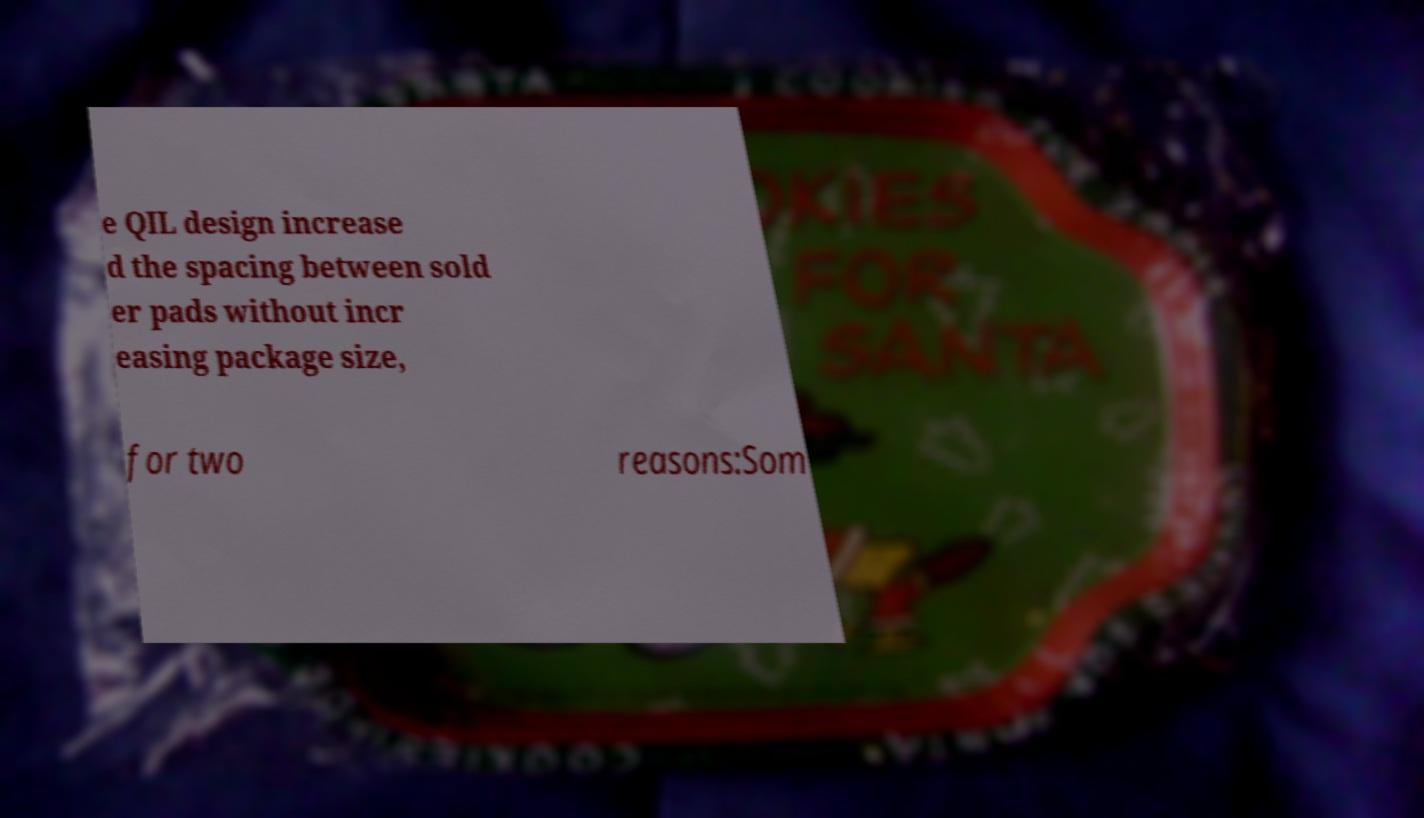Could you assist in decoding the text presented in this image and type it out clearly? e QIL design increase d the spacing between sold er pads without incr easing package size, for two reasons:Som 